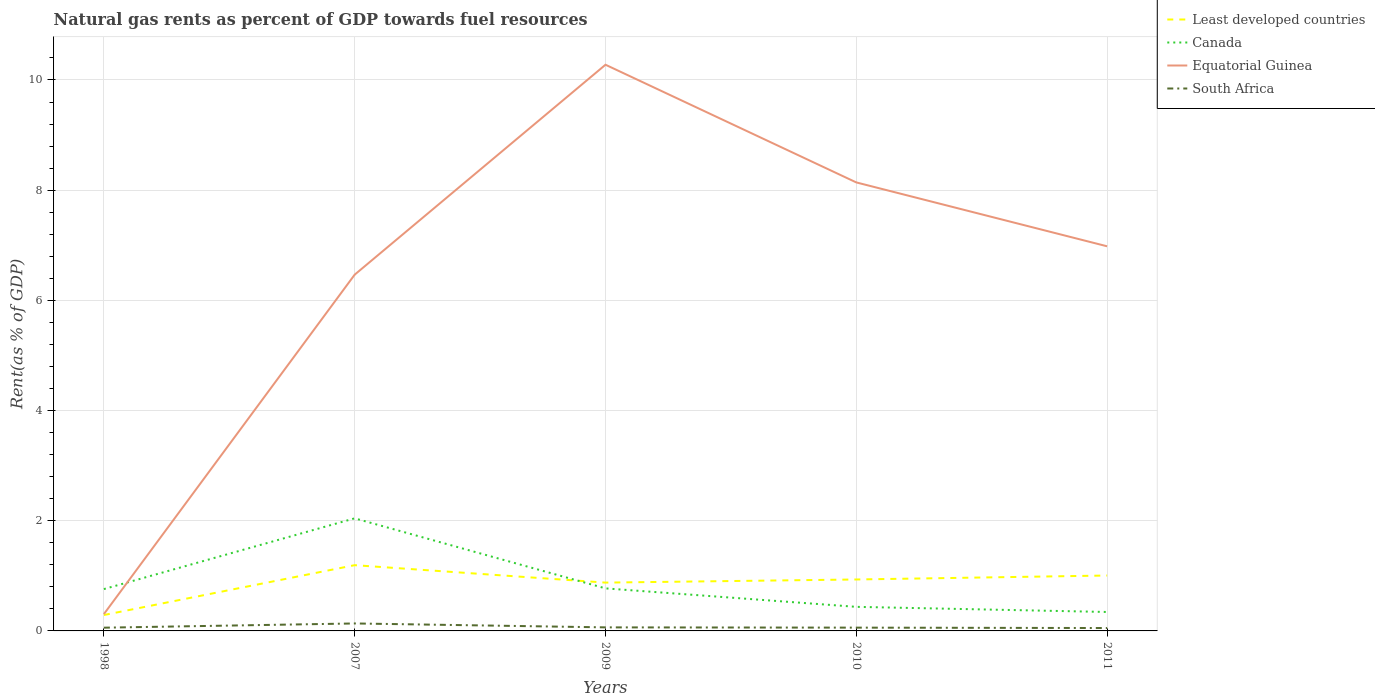Is the number of lines equal to the number of legend labels?
Offer a very short reply. Yes. Across all years, what is the maximum matural gas rent in South Africa?
Offer a very short reply. 0.05. What is the total matural gas rent in Equatorial Guinea in the graph?
Make the answer very short. -6.68. What is the difference between the highest and the second highest matural gas rent in Canada?
Provide a succinct answer. 1.7. What is the difference between the highest and the lowest matural gas rent in Least developed countries?
Ensure brevity in your answer.  4. How many years are there in the graph?
Offer a very short reply. 5. Are the values on the major ticks of Y-axis written in scientific E-notation?
Provide a short and direct response. No. Does the graph contain grids?
Offer a very short reply. Yes. Where does the legend appear in the graph?
Give a very brief answer. Top right. How many legend labels are there?
Your answer should be very brief. 4. How are the legend labels stacked?
Provide a short and direct response. Vertical. What is the title of the graph?
Keep it short and to the point. Natural gas rents as percent of GDP towards fuel resources. Does "Afghanistan" appear as one of the legend labels in the graph?
Your answer should be very brief. No. What is the label or title of the Y-axis?
Offer a very short reply. Rent(as % of GDP). What is the Rent(as % of GDP) in Least developed countries in 1998?
Give a very brief answer. 0.29. What is the Rent(as % of GDP) of Canada in 1998?
Make the answer very short. 0.76. What is the Rent(as % of GDP) in Equatorial Guinea in 1998?
Offer a very short reply. 0.31. What is the Rent(as % of GDP) of South Africa in 1998?
Ensure brevity in your answer.  0.06. What is the Rent(as % of GDP) in Least developed countries in 2007?
Your answer should be very brief. 1.19. What is the Rent(as % of GDP) of Canada in 2007?
Give a very brief answer. 2.04. What is the Rent(as % of GDP) of Equatorial Guinea in 2007?
Your response must be concise. 6.47. What is the Rent(as % of GDP) in South Africa in 2007?
Your answer should be very brief. 0.14. What is the Rent(as % of GDP) in Least developed countries in 2009?
Offer a very short reply. 0.88. What is the Rent(as % of GDP) in Canada in 2009?
Your answer should be compact. 0.77. What is the Rent(as % of GDP) of Equatorial Guinea in 2009?
Make the answer very short. 10.28. What is the Rent(as % of GDP) in South Africa in 2009?
Your answer should be compact. 0.06. What is the Rent(as % of GDP) of Least developed countries in 2010?
Provide a succinct answer. 0.93. What is the Rent(as % of GDP) of Canada in 2010?
Give a very brief answer. 0.44. What is the Rent(as % of GDP) in Equatorial Guinea in 2010?
Offer a very short reply. 8.14. What is the Rent(as % of GDP) of South Africa in 2010?
Your answer should be very brief. 0.06. What is the Rent(as % of GDP) in Least developed countries in 2011?
Your answer should be compact. 1.01. What is the Rent(as % of GDP) of Canada in 2011?
Provide a short and direct response. 0.34. What is the Rent(as % of GDP) in Equatorial Guinea in 2011?
Provide a short and direct response. 6.98. What is the Rent(as % of GDP) in South Africa in 2011?
Ensure brevity in your answer.  0.05. Across all years, what is the maximum Rent(as % of GDP) of Least developed countries?
Provide a short and direct response. 1.19. Across all years, what is the maximum Rent(as % of GDP) of Canada?
Offer a very short reply. 2.04. Across all years, what is the maximum Rent(as % of GDP) in Equatorial Guinea?
Provide a succinct answer. 10.28. Across all years, what is the maximum Rent(as % of GDP) in South Africa?
Ensure brevity in your answer.  0.14. Across all years, what is the minimum Rent(as % of GDP) of Least developed countries?
Offer a terse response. 0.29. Across all years, what is the minimum Rent(as % of GDP) in Canada?
Your answer should be compact. 0.34. Across all years, what is the minimum Rent(as % of GDP) in Equatorial Guinea?
Give a very brief answer. 0.31. Across all years, what is the minimum Rent(as % of GDP) of South Africa?
Your response must be concise. 0.05. What is the total Rent(as % of GDP) of Least developed countries in the graph?
Ensure brevity in your answer.  4.3. What is the total Rent(as % of GDP) of Canada in the graph?
Keep it short and to the point. 4.36. What is the total Rent(as % of GDP) in Equatorial Guinea in the graph?
Ensure brevity in your answer.  32.17. What is the total Rent(as % of GDP) in South Africa in the graph?
Give a very brief answer. 0.37. What is the difference between the Rent(as % of GDP) of Least developed countries in 1998 and that in 2007?
Make the answer very short. -0.91. What is the difference between the Rent(as % of GDP) in Canada in 1998 and that in 2007?
Your answer should be very brief. -1.28. What is the difference between the Rent(as % of GDP) of Equatorial Guinea in 1998 and that in 2007?
Your response must be concise. -6.16. What is the difference between the Rent(as % of GDP) in South Africa in 1998 and that in 2007?
Make the answer very short. -0.08. What is the difference between the Rent(as % of GDP) of Least developed countries in 1998 and that in 2009?
Offer a very short reply. -0.59. What is the difference between the Rent(as % of GDP) in Canada in 1998 and that in 2009?
Give a very brief answer. -0.01. What is the difference between the Rent(as % of GDP) of Equatorial Guinea in 1998 and that in 2009?
Provide a succinct answer. -9.97. What is the difference between the Rent(as % of GDP) in South Africa in 1998 and that in 2009?
Your response must be concise. -0.01. What is the difference between the Rent(as % of GDP) of Least developed countries in 1998 and that in 2010?
Keep it short and to the point. -0.65. What is the difference between the Rent(as % of GDP) in Canada in 1998 and that in 2010?
Offer a very short reply. 0.32. What is the difference between the Rent(as % of GDP) in Equatorial Guinea in 1998 and that in 2010?
Your answer should be very brief. -7.84. What is the difference between the Rent(as % of GDP) of South Africa in 1998 and that in 2010?
Your answer should be compact. -0. What is the difference between the Rent(as % of GDP) of Least developed countries in 1998 and that in 2011?
Offer a terse response. -0.72. What is the difference between the Rent(as % of GDP) of Canada in 1998 and that in 2011?
Provide a short and direct response. 0.42. What is the difference between the Rent(as % of GDP) of Equatorial Guinea in 1998 and that in 2011?
Keep it short and to the point. -6.68. What is the difference between the Rent(as % of GDP) of South Africa in 1998 and that in 2011?
Keep it short and to the point. 0.01. What is the difference between the Rent(as % of GDP) in Least developed countries in 2007 and that in 2009?
Your answer should be very brief. 0.32. What is the difference between the Rent(as % of GDP) of Canada in 2007 and that in 2009?
Keep it short and to the point. 1.27. What is the difference between the Rent(as % of GDP) of Equatorial Guinea in 2007 and that in 2009?
Your answer should be very brief. -3.81. What is the difference between the Rent(as % of GDP) in South Africa in 2007 and that in 2009?
Offer a very short reply. 0.07. What is the difference between the Rent(as % of GDP) in Least developed countries in 2007 and that in 2010?
Keep it short and to the point. 0.26. What is the difference between the Rent(as % of GDP) in Canada in 2007 and that in 2010?
Give a very brief answer. 1.61. What is the difference between the Rent(as % of GDP) in Equatorial Guinea in 2007 and that in 2010?
Offer a very short reply. -1.67. What is the difference between the Rent(as % of GDP) of South Africa in 2007 and that in 2010?
Offer a very short reply. 0.08. What is the difference between the Rent(as % of GDP) in Least developed countries in 2007 and that in 2011?
Offer a very short reply. 0.19. What is the difference between the Rent(as % of GDP) of Canada in 2007 and that in 2011?
Make the answer very short. 1.7. What is the difference between the Rent(as % of GDP) of Equatorial Guinea in 2007 and that in 2011?
Provide a succinct answer. -0.51. What is the difference between the Rent(as % of GDP) of South Africa in 2007 and that in 2011?
Keep it short and to the point. 0.08. What is the difference between the Rent(as % of GDP) of Least developed countries in 2009 and that in 2010?
Your answer should be compact. -0.06. What is the difference between the Rent(as % of GDP) in Canada in 2009 and that in 2010?
Provide a short and direct response. 0.34. What is the difference between the Rent(as % of GDP) of Equatorial Guinea in 2009 and that in 2010?
Offer a terse response. 2.14. What is the difference between the Rent(as % of GDP) of South Africa in 2009 and that in 2010?
Make the answer very short. 0. What is the difference between the Rent(as % of GDP) in Least developed countries in 2009 and that in 2011?
Keep it short and to the point. -0.13. What is the difference between the Rent(as % of GDP) in Canada in 2009 and that in 2011?
Give a very brief answer. 0.43. What is the difference between the Rent(as % of GDP) of Equatorial Guinea in 2009 and that in 2011?
Give a very brief answer. 3.3. What is the difference between the Rent(as % of GDP) of South Africa in 2009 and that in 2011?
Provide a succinct answer. 0.01. What is the difference between the Rent(as % of GDP) of Least developed countries in 2010 and that in 2011?
Ensure brevity in your answer.  -0.07. What is the difference between the Rent(as % of GDP) in Canada in 2010 and that in 2011?
Offer a terse response. 0.09. What is the difference between the Rent(as % of GDP) in Equatorial Guinea in 2010 and that in 2011?
Make the answer very short. 1.16. What is the difference between the Rent(as % of GDP) in South Africa in 2010 and that in 2011?
Ensure brevity in your answer.  0.01. What is the difference between the Rent(as % of GDP) of Least developed countries in 1998 and the Rent(as % of GDP) of Canada in 2007?
Offer a terse response. -1.76. What is the difference between the Rent(as % of GDP) of Least developed countries in 1998 and the Rent(as % of GDP) of Equatorial Guinea in 2007?
Provide a succinct answer. -6.18. What is the difference between the Rent(as % of GDP) of Least developed countries in 1998 and the Rent(as % of GDP) of South Africa in 2007?
Give a very brief answer. 0.15. What is the difference between the Rent(as % of GDP) of Canada in 1998 and the Rent(as % of GDP) of Equatorial Guinea in 2007?
Keep it short and to the point. -5.71. What is the difference between the Rent(as % of GDP) of Canada in 1998 and the Rent(as % of GDP) of South Africa in 2007?
Make the answer very short. 0.62. What is the difference between the Rent(as % of GDP) in Equatorial Guinea in 1998 and the Rent(as % of GDP) in South Africa in 2007?
Provide a succinct answer. 0.17. What is the difference between the Rent(as % of GDP) of Least developed countries in 1998 and the Rent(as % of GDP) of Canada in 2009?
Keep it short and to the point. -0.48. What is the difference between the Rent(as % of GDP) in Least developed countries in 1998 and the Rent(as % of GDP) in Equatorial Guinea in 2009?
Your answer should be very brief. -9.99. What is the difference between the Rent(as % of GDP) in Least developed countries in 1998 and the Rent(as % of GDP) in South Africa in 2009?
Make the answer very short. 0.22. What is the difference between the Rent(as % of GDP) in Canada in 1998 and the Rent(as % of GDP) in Equatorial Guinea in 2009?
Give a very brief answer. -9.52. What is the difference between the Rent(as % of GDP) of Canada in 1998 and the Rent(as % of GDP) of South Africa in 2009?
Ensure brevity in your answer.  0.69. What is the difference between the Rent(as % of GDP) of Equatorial Guinea in 1998 and the Rent(as % of GDP) of South Africa in 2009?
Keep it short and to the point. 0.24. What is the difference between the Rent(as % of GDP) in Least developed countries in 1998 and the Rent(as % of GDP) in Canada in 2010?
Offer a very short reply. -0.15. What is the difference between the Rent(as % of GDP) in Least developed countries in 1998 and the Rent(as % of GDP) in Equatorial Guinea in 2010?
Provide a short and direct response. -7.85. What is the difference between the Rent(as % of GDP) in Least developed countries in 1998 and the Rent(as % of GDP) in South Africa in 2010?
Your answer should be compact. 0.23. What is the difference between the Rent(as % of GDP) in Canada in 1998 and the Rent(as % of GDP) in Equatorial Guinea in 2010?
Ensure brevity in your answer.  -7.38. What is the difference between the Rent(as % of GDP) in Canada in 1998 and the Rent(as % of GDP) in South Africa in 2010?
Provide a short and direct response. 0.7. What is the difference between the Rent(as % of GDP) of Equatorial Guinea in 1998 and the Rent(as % of GDP) of South Africa in 2010?
Provide a succinct answer. 0.25. What is the difference between the Rent(as % of GDP) of Least developed countries in 1998 and the Rent(as % of GDP) of Canada in 2011?
Your response must be concise. -0.06. What is the difference between the Rent(as % of GDP) in Least developed countries in 1998 and the Rent(as % of GDP) in Equatorial Guinea in 2011?
Provide a succinct answer. -6.69. What is the difference between the Rent(as % of GDP) in Least developed countries in 1998 and the Rent(as % of GDP) in South Africa in 2011?
Offer a terse response. 0.24. What is the difference between the Rent(as % of GDP) in Canada in 1998 and the Rent(as % of GDP) in Equatorial Guinea in 2011?
Your answer should be very brief. -6.22. What is the difference between the Rent(as % of GDP) of Canada in 1998 and the Rent(as % of GDP) of South Africa in 2011?
Give a very brief answer. 0.71. What is the difference between the Rent(as % of GDP) of Equatorial Guinea in 1998 and the Rent(as % of GDP) of South Africa in 2011?
Provide a succinct answer. 0.25. What is the difference between the Rent(as % of GDP) of Least developed countries in 2007 and the Rent(as % of GDP) of Canada in 2009?
Offer a terse response. 0.42. What is the difference between the Rent(as % of GDP) of Least developed countries in 2007 and the Rent(as % of GDP) of Equatorial Guinea in 2009?
Make the answer very short. -9.08. What is the difference between the Rent(as % of GDP) of Least developed countries in 2007 and the Rent(as % of GDP) of South Africa in 2009?
Ensure brevity in your answer.  1.13. What is the difference between the Rent(as % of GDP) of Canada in 2007 and the Rent(as % of GDP) of Equatorial Guinea in 2009?
Your answer should be compact. -8.23. What is the difference between the Rent(as % of GDP) of Canada in 2007 and the Rent(as % of GDP) of South Africa in 2009?
Give a very brief answer. 1.98. What is the difference between the Rent(as % of GDP) of Equatorial Guinea in 2007 and the Rent(as % of GDP) of South Africa in 2009?
Keep it short and to the point. 6.4. What is the difference between the Rent(as % of GDP) of Least developed countries in 2007 and the Rent(as % of GDP) of Canada in 2010?
Ensure brevity in your answer.  0.76. What is the difference between the Rent(as % of GDP) in Least developed countries in 2007 and the Rent(as % of GDP) in Equatorial Guinea in 2010?
Make the answer very short. -6.95. What is the difference between the Rent(as % of GDP) in Least developed countries in 2007 and the Rent(as % of GDP) in South Africa in 2010?
Provide a succinct answer. 1.13. What is the difference between the Rent(as % of GDP) of Canada in 2007 and the Rent(as % of GDP) of Equatorial Guinea in 2010?
Offer a terse response. -6.1. What is the difference between the Rent(as % of GDP) of Canada in 2007 and the Rent(as % of GDP) of South Africa in 2010?
Your response must be concise. 1.98. What is the difference between the Rent(as % of GDP) in Equatorial Guinea in 2007 and the Rent(as % of GDP) in South Africa in 2010?
Give a very brief answer. 6.41. What is the difference between the Rent(as % of GDP) in Least developed countries in 2007 and the Rent(as % of GDP) in Canada in 2011?
Your answer should be compact. 0.85. What is the difference between the Rent(as % of GDP) in Least developed countries in 2007 and the Rent(as % of GDP) in Equatorial Guinea in 2011?
Offer a terse response. -5.79. What is the difference between the Rent(as % of GDP) in Least developed countries in 2007 and the Rent(as % of GDP) in South Africa in 2011?
Your response must be concise. 1.14. What is the difference between the Rent(as % of GDP) in Canada in 2007 and the Rent(as % of GDP) in Equatorial Guinea in 2011?
Make the answer very short. -4.94. What is the difference between the Rent(as % of GDP) of Canada in 2007 and the Rent(as % of GDP) of South Africa in 2011?
Give a very brief answer. 1.99. What is the difference between the Rent(as % of GDP) in Equatorial Guinea in 2007 and the Rent(as % of GDP) in South Africa in 2011?
Give a very brief answer. 6.41. What is the difference between the Rent(as % of GDP) of Least developed countries in 2009 and the Rent(as % of GDP) of Canada in 2010?
Your answer should be very brief. 0.44. What is the difference between the Rent(as % of GDP) in Least developed countries in 2009 and the Rent(as % of GDP) in Equatorial Guinea in 2010?
Your answer should be compact. -7.26. What is the difference between the Rent(as % of GDP) of Least developed countries in 2009 and the Rent(as % of GDP) of South Africa in 2010?
Your answer should be compact. 0.82. What is the difference between the Rent(as % of GDP) of Canada in 2009 and the Rent(as % of GDP) of Equatorial Guinea in 2010?
Provide a short and direct response. -7.37. What is the difference between the Rent(as % of GDP) in Canada in 2009 and the Rent(as % of GDP) in South Africa in 2010?
Give a very brief answer. 0.71. What is the difference between the Rent(as % of GDP) of Equatorial Guinea in 2009 and the Rent(as % of GDP) of South Africa in 2010?
Your answer should be compact. 10.22. What is the difference between the Rent(as % of GDP) in Least developed countries in 2009 and the Rent(as % of GDP) in Canada in 2011?
Provide a succinct answer. 0.53. What is the difference between the Rent(as % of GDP) of Least developed countries in 2009 and the Rent(as % of GDP) of Equatorial Guinea in 2011?
Your answer should be very brief. -6.1. What is the difference between the Rent(as % of GDP) in Least developed countries in 2009 and the Rent(as % of GDP) in South Africa in 2011?
Your answer should be compact. 0.82. What is the difference between the Rent(as % of GDP) in Canada in 2009 and the Rent(as % of GDP) in Equatorial Guinea in 2011?
Give a very brief answer. -6.21. What is the difference between the Rent(as % of GDP) of Canada in 2009 and the Rent(as % of GDP) of South Africa in 2011?
Your answer should be very brief. 0.72. What is the difference between the Rent(as % of GDP) in Equatorial Guinea in 2009 and the Rent(as % of GDP) in South Africa in 2011?
Keep it short and to the point. 10.22. What is the difference between the Rent(as % of GDP) of Least developed countries in 2010 and the Rent(as % of GDP) of Canada in 2011?
Give a very brief answer. 0.59. What is the difference between the Rent(as % of GDP) in Least developed countries in 2010 and the Rent(as % of GDP) in Equatorial Guinea in 2011?
Offer a very short reply. -6.05. What is the difference between the Rent(as % of GDP) in Least developed countries in 2010 and the Rent(as % of GDP) in South Africa in 2011?
Offer a very short reply. 0.88. What is the difference between the Rent(as % of GDP) in Canada in 2010 and the Rent(as % of GDP) in Equatorial Guinea in 2011?
Provide a short and direct response. -6.54. What is the difference between the Rent(as % of GDP) in Canada in 2010 and the Rent(as % of GDP) in South Africa in 2011?
Your response must be concise. 0.38. What is the difference between the Rent(as % of GDP) of Equatorial Guinea in 2010 and the Rent(as % of GDP) of South Africa in 2011?
Offer a terse response. 8.09. What is the average Rent(as % of GDP) in Least developed countries per year?
Your answer should be very brief. 0.86. What is the average Rent(as % of GDP) in Canada per year?
Offer a terse response. 0.87. What is the average Rent(as % of GDP) of Equatorial Guinea per year?
Your answer should be compact. 6.43. What is the average Rent(as % of GDP) of South Africa per year?
Your response must be concise. 0.07. In the year 1998, what is the difference between the Rent(as % of GDP) in Least developed countries and Rent(as % of GDP) in Canada?
Your answer should be compact. -0.47. In the year 1998, what is the difference between the Rent(as % of GDP) of Least developed countries and Rent(as % of GDP) of Equatorial Guinea?
Provide a succinct answer. -0.02. In the year 1998, what is the difference between the Rent(as % of GDP) in Least developed countries and Rent(as % of GDP) in South Africa?
Your answer should be compact. 0.23. In the year 1998, what is the difference between the Rent(as % of GDP) in Canada and Rent(as % of GDP) in Equatorial Guinea?
Offer a terse response. 0.45. In the year 1998, what is the difference between the Rent(as % of GDP) in Canada and Rent(as % of GDP) in South Africa?
Your answer should be very brief. 0.7. In the year 1998, what is the difference between the Rent(as % of GDP) of Equatorial Guinea and Rent(as % of GDP) of South Africa?
Ensure brevity in your answer.  0.25. In the year 2007, what is the difference between the Rent(as % of GDP) of Least developed countries and Rent(as % of GDP) of Canada?
Give a very brief answer. -0.85. In the year 2007, what is the difference between the Rent(as % of GDP) of Least developed countries and Rent(as % of GDP) of Equatorial Guinea?
Provide a succinct answer. -5.27. In the year 2007, what is the difference between the Rent(as % of GDP) of Least developed countries and Rent(as % of GDP) of South Africa?
Your response must be concise. 1.06. In the year 2007, what is the difference between the Rent(as % of GDP) of Canada and Rent(as % of GDP) of Equatorial Guinea?
Make the answer very short. -4.42. In the year 2007, what is the difference between the Rent(as % of GDP) of Canada and Rent(as % of GDP) of South Africa?
Your answer should be very brief. 1.91. In the year 2007, what is the difference between the Rent(as % of GDP) in Equatorial Guinea and Rent(as % of GDP) in South Africa?
Offer a very short reply. 6.33. In the year 2009, what is the difference between the Rent(as % of GDP) of Least developed countries and Rent(as % of GDP) of Canada?
Your answer should be very brief. 0.1. In the year 2009, what is the difference between the Rent(as % of GDP) of Least developed countries and Rent(as % of GDP) of Equatorial Guinea?
Make the answer very short. -9.4. In the year 2009, what is the difference between the Rent(as % of GDP) in Least developed countries and Rent(as % of GDP) in South Africa?
Keep it short and to the point. 0.81. In the year 2009, what is the difference between the Rent(as % of GDP) in Canada and Rent(as % of GDP) in Equatorial Guinea?
Your answer should be very brief. -9.5. In the year 2009, what is the difference between the Rent(as % of GDP) in Canada and Rent(as % of GDP) in South Africa?
Your answer should be compact. 0.71. In the year 2009, what is the difference between the Rent(as % of GDP) in Equatorial Guinea and Rent(as % of GDP) in South Africa?
Your answer should be compact. 10.21. In the year 2010, what is the difference between the Rent(as % of GDP) of Least developed countries and Rent(as % of GDP) of Canada?
Your response must be concise. 0.5. In the year 2010, what is the difference between the Rent(as % of GDP) in Least developed countries and Rent(as % of GDP) in Equatorial Guinea?
Keep it short and to the point. -7.21. In the year 2010, what is the difference between the Rent(as % of GDP) of Least developed countries and Rent(as % of GDP) of South Africa?
Your response must be concise. 0.87. In the year 2010, what is the difference between the Rent(as % of GDP) of Canada and Rent(as % of GDP) of Equatorial Guinea?
Your response must be concise. -7.7. In the year 2010, what is the difference between the Rent(as % of GDP) of Canada and Rent(as % of GDP) of South Africa?
Make the answer very short. 0.38. In the year 2010, what is the difference between the Rent(as % of GDP) in Equatorial Guinea and Rent(as % of GDP) in South Africa?
Your response must be concise. 8.08. In the year 2011, what is the difference between the Rent(as % of GDP) of Least developed countries and Rent(as % of GDP) of Canada?
Your answer should be compact. 0.66. In the year 2011, what is the difference between the Rent(as % of GDP) in Least developed countries and Rent(as % of GDP) in Equatorial Guinea?
Your response must be concise. -5.98. In the year 2011, what is the difference between the Rent(as % of GDP) of Least developed countries and Rent(as % of GDP) of South Africa?
Your answer should be compact. 0.95. In the year 2011, what is the difference between the Rent(as % of GDP) in Canada and Rent(as % of GDP) in Equatorial Guinea?
Offer a terse response. -6.64. In the year 2011, what is the difference between the Rent(as % of GDP) of Canada and Rent(as % of GDP) of South Africa?
Give a very brief answer. 0.29. In the year 2011, what is the difference between the Rent(as % of GDP) of Equatorial Guinea and Rent(as % of GDP) of South Africa?
Keep it short and to the point. 6.93. What is the ratio of the Rent(as % of GDP) in Least developed countries in 1998 to that in 2007?
Give a very brief answer. 0.24. What is the ratio of the Rent(as % of GDP) of Canada in 1998 to that in 2007?
Your answer should be very brief. 0.37. What is the ratio of the Rent(as % of GDP) in Equatorial Guinea in 1998 to that in 2007?
Provide a short and direct response. 0.05. What is the ratio of the Rent(as % of GDP) of South Africa in 1998 to that in 2007?
Your response must be concise. 0.43. What is the ratio of the Rent(as % of GDP) in Least developed countries in 1998 to that in 2009?
Make the answer very short. 0.33. What is the ratio of the Rent(as % of GDP) of Canada in 1998 to that in 2009?
Your answer should be very brief. 0.98. What is the ratio of the Rent(as % of GDP) in Equatorial Guinea in 1998 to that in 2009?
Your answer should be very brief. 0.03. What is the ratio of the Rent(as % of GDP) in South Africa in 1998 to that in 2009?
Ensure brevity in your answer.  0.91. What is the ratio of the Rent(as % of GDP) of Least developed countries in 1998 to that in 2010?
Your response must be concise. 0.31. What is the ratio of the Rent(as % of GDP) of Canada in 1998 to that in 2010?
Provide a succinct answer. 1.74. What is the ratio of the Rent(as % of GDP) of Equatorial Guinea in 1998 to that in 2010?
Provide a succinct answer. 0.04. What is the ratio of the Rent(as % of GDP) in South Africa in 1998 to that in 2010?
Your answer should be compact. 0.99. What is the ratio of the Rent(as % of GDP) in Least developed countries in 1998 to that in 2011?
Provide a succinct answer. 0.29. What is the ratio of the Rent(as % of GDP) in Canada in 1998 to that in 2011?
Ensure brevity in your answer.  2.21. What is the ratio of the Rent(as % of GDP) of Equatorial Guinea in 1998 to that in 2011?
Offer a very short reply. 0.04. What is the ratio of the Rent(as % of GDP) of South Africa in 1998 to that in 2011?
Give a very brief answer. 1.12. What is the ratio of the Rent(as % of GDP) in Least developed countries in 2007 to that in 2009?
Ensure brevity in your answer.  1.36. What is the ratio of the Rent(as % of GDP) in Canada in 2007 to that in 2009?
Your response must be concise. 2.65. What is the ratio of the Rent(as % of GDP) of Equatorial Guinea in 2007 to that in 2009?
Make the answer very short. 0.63. What is the ratio of the Rent(as % of GDP) in South Africa in 2007 to that in 2009?
Your answer should be compact. 2.1. What is the ratio of the Rent(as % of GDP) of Least developed countries in 2007 to that in 2010?
Your answer should be very brief. 1.28. What is the ratio of the Rent(as % of GDP) in Canada in 2007 to that in 2010?
Keep it short and to the point. 4.68. What is the ratio of the Rent(as % of GDP) of Equatorial Guinea in 2007 to that in 2010?
Provide a succinct answer. 0.79. What is the ratio of the Rent(as % of GDP) of South Africa in 2007 to that in 2010?
Your response must be concise. 2.27. What is the ratio of the Rent(as % of GDP) in Least developed countries in 2007 to that in 2011?
Offer a terse response. 1.19. What is the ratio of the Rent(as % of GDP) of Canada in 2007 to that in 2011?
Ensure brevity in your answer.  5.94. What is the ratio of the Rent(as % of GDP) in Equatorial Guinea in 2007 to that in 2011?
Ensure brevity in your answer.  0.93. What is the ratio of the Rent(as % of GDP) of South Africa in 2007 to that in 2011?
Your answer should be compact. 2.58. What is the ratio of the Rent(as % of GDP) of Least developed countries in 2009 to that in 2010?
Your response must be concise. 0.94. What is the ratio of the Rent(as % of GDP) of Canada in 2009 to that in 2010?
Offer a terse response. 1.77. What is the ratio of the Rent(as % of GDP) of Equatorial Guinea in 2009 to that in 2010?
Provide a short and direct response. 1.26. What is the ratio of the Rent(as % of GDP) in South Africa in 2009 to that in 2010?
Make the answer very short. 1.08. What is the ratio of the Rent(as % of GDP) in Least developed countries in 2009 to that in 2011?
Your response must be concise. 0.87. What is the ratio of the Rent(as % of GDP) in Canada in 2009 to that in 2011?
Your answer should be very brief. 2.25. What is the ratio of the Rent(as % of GDP) of Equatorial Guinea in 2009 to that in 2011?
Give a very brief answer. 1.47. What is the ratio of the Rent(as % of GDP) in South Africa in 2009 to that in 2011?
Provide a succinct answer. 1.23. What is the ratio of the Rent(as % of GDP) of Least developed countries in 2010 to that in 2011?
Give a very brief answer. 0.93. What is the ratio of the Rent(as % of GDP) of Canada in 2010 to that in 2011?
Offer a very short reply. 1.27. What is the ratio of the Rent(as % of GDP) in Equatorial Guinea in 2010 to that in 2011?
Offer a terse response. 1.17. What is the ratio of the Rent(as % of GDP) in South Africa in 2010 to that in 2011?
Offer a terse response. 1.14. What is the difference between the highest and the second highest Rent(as % of GDP) in Least developed countries?
Offer a terse response. 0.19. What is the difference between the highest and the second highest Rent(as % of GDP) in Canada?
Offer a very short reply. 1.27. What is the difference between the highest and the second highest Rent(as % of GDP) in Equatorial Guinea?
Offer a terse response. 2.14. What is the difference between the highest and the second highest Rent(as % of GDP) in South Africa?
Provide a succinct answer. 0.07. What is the difference between the highest and the lowest Rent(as % of GDP) of Least developed countries?
Give a very brief answer. 0.91. What is the difference between the highest and the lowest Rent(as % of GDP) in Canada?
Your answer should be compact. 1.7. What is the difference between the highest and the lowest Rent(as % of GDP) in Equatorial Guinea?
Your answer should be very brief. 9.97. What is the difference between the highest and the lowest Rent(as % of GDP) of South Africa?
Provide a short and direct response. 0.08. 